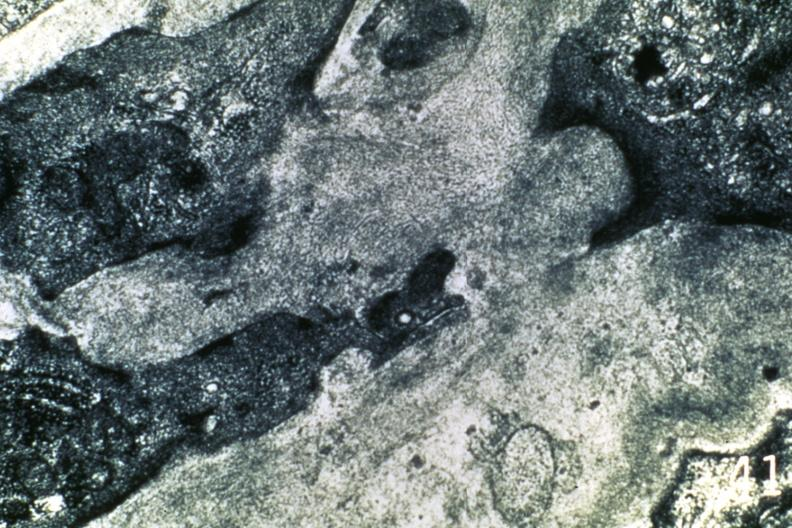s peritoneum present?
Answer the question using a single word or phrase. No 